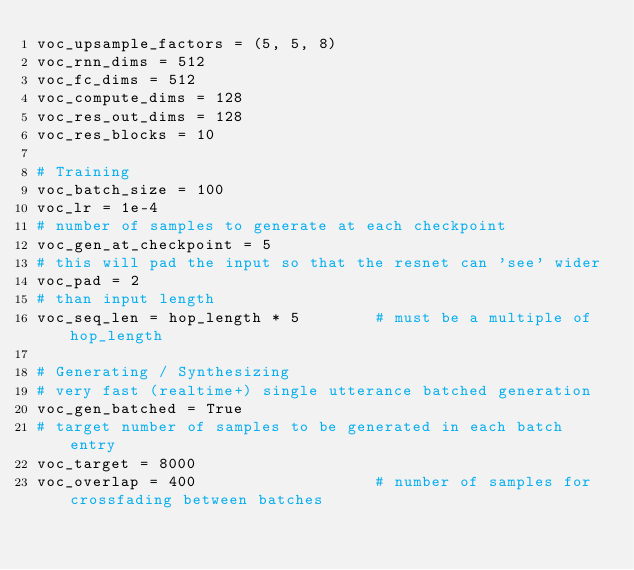Convert code to text. <code><loc_0><loc_0><loc_500><loc_500><_Python_>voc_upsample_factors = (5, 5, 8)
voc_rnn_dims = 512
voc_fc_dims = 512
voc_compute_dims = 128
voc_res_out_dims = 128
voc_res_blocks = 10

# Training
voc_batch_size = 100
voc_lr = 1e-4
# number of samples to generate at each checkpoint
voc_gen_at_checkpoint = 5
# this will pad the input so that the resnet can 'see' wider
voc_pad = 2
# than input length
voc_seq_len = hop_length * 5        # must be a multiple of hop_length

# Generating / Synthesizing
# very fast (realtime+) single utterance batched generation
voc_gen_batched = True
# target number of samples to be generated in each batch entry
voc_target = 8000
voc_overlap = 400                   # number of samples for crossfading between batches
</code> 